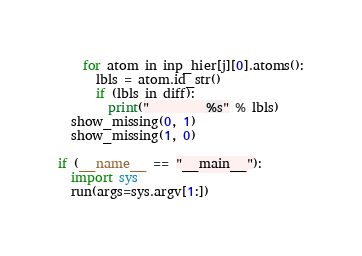<code> <loc_0><loc_0><loc_500><loc_500><_Python_>    for atom in inp_hier[j][0].atoms():
      lbls = atom.id_str()
      if (lbls in diff):
        print("         %s" % lbls)
  show_missing(0, 1)
  show_missing(1, 0)

if (__name__ == "__main__"):
  import sys
  run(args=sys.argv[1:])
</code> 